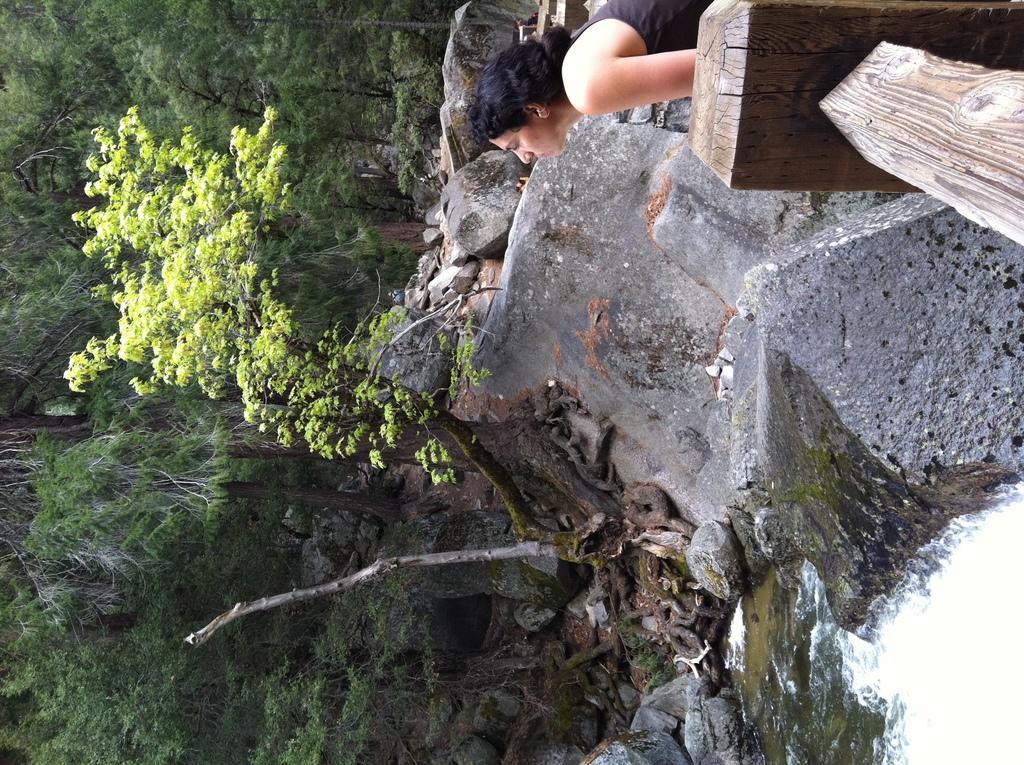How would you summarize this image in a sentence or two? In the foreground of this image, we see a pond, tree, and few stones. On top of the image, there is a woman near wooden railing. On left, we see few trees. 